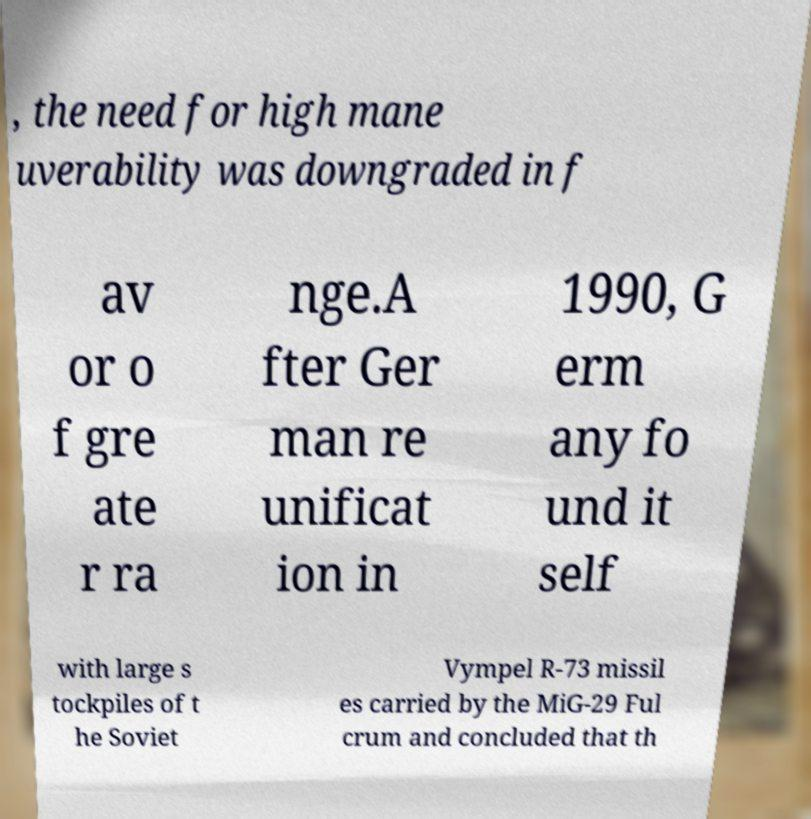There's text embedded in this image that I need extracted. Can you transcribe it verbatim? , the need for high mane uverability was downgraded in f av or o f gre ate r ra nge.A fter Ger man re unificat ion in 1990, G erm any fo und it self with large s tockpiles of t he Soviet Vympel R-73 missil es carried by the MiG-29 Ful crum and concluded that th 